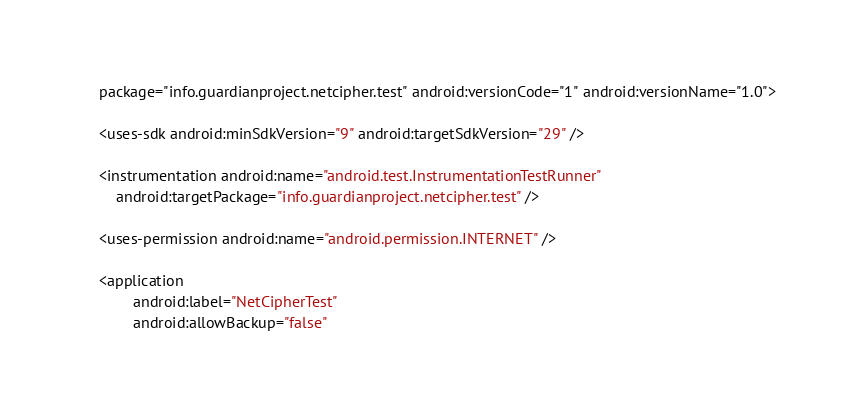Convert code to text. <code><loc_0><loc_0><loc_500><loc_500><_XML_>    package="info.guardianproject.netcipher.test" android:versionCode="1" android:versionName="1.0">

    <uses-sdk android:minSdkVersion="9" android:targetSdkVersion="29" />

    <instrumentation android:name="android.test.InstrumentationTestRunner"
        android:targetPackage="info.guardianproject.netcipher.test" />

    <uses-permission android:name="android.permission.INTERNET" />

    <application
            android:label="NetCipherTest"
            android:allowBackup="false"</code> 